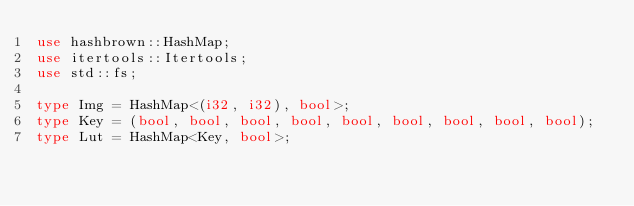<code> <loc_0><loc_0><loc_500><loc_500><_Rust_>use hashbrown::HashMap;
use itertools::Itertools;
use std::fs;

type Img = HashMap<(i32, i32), bool>;
type Key = (bool, bool, bool, bool, bool, bool, bool, bool, bool);
type Lut = HashMap<Key, bool>;
</code> 